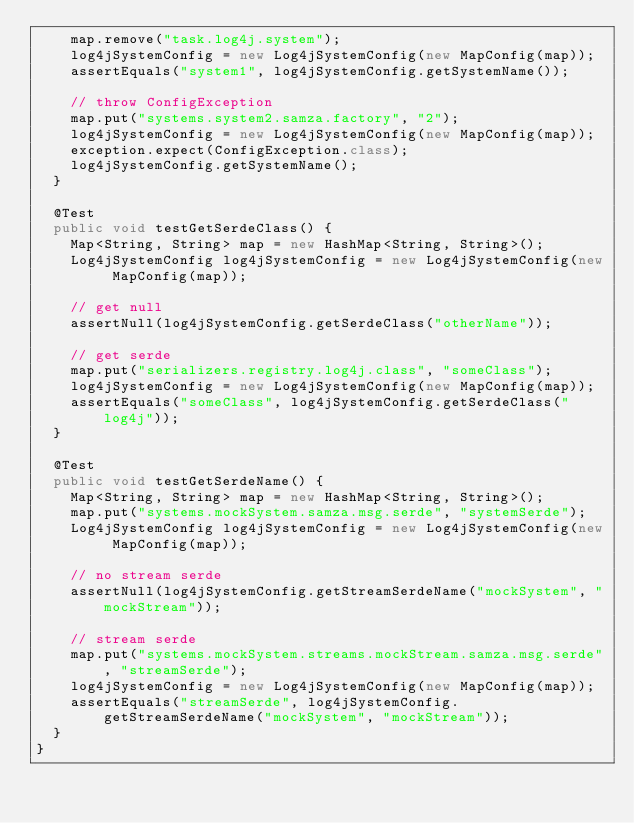<code> <loc_0><loc_0><loc_500><loc_500><_Java_>    map.remove("task.log4j.system");
    log4jSystemConfig = new Log4jSystemConfig(new MapConfig(map));
    assertEquals("system1", log4jSystemConfig.getSystemName());

    // throw ConfigException
    map.put("systems.system2.samza.factory", "2");
    log4jSystemConfig = new Log4jSystemConfig(new MapConfig(map));
    exception.expect(ConfigException.class);
    log4jSystemConfig.getSystemName();
  }

  @Test
  public void testGetSerdeClass() {
    Map<String, String> map = new HashMap<String, String>();
    Log4jSystemConfig log4jSystemConfig = new Log4jSystemConfig(new MapConfig(map));

    // get null
    assertNull(log4jSystemConfig.getSerdeClass("otherName"));

    // get serde
    map.put("serializers.registry.log4j.class", "someClass");
    log4jSystemConfig = new Log4jSystemConfig(new MapConfig(map));
    assertEquals("someClass", log4jSystemConfig.getSerdeClass("log4j"));
  }

  @Test
  public void testGetSerdeName() {
    Map<String, String> map = new HashMap<String, String>();
    map.put("systems.mockSystem.samza.msg.serde", "systemSerde");
    Log4jSystemConfig log4jSystemConfig = new Log4jSystemConfig(new MapConfig(map));

    // no stream serde
    assertNull(log4jSystemConfig.getStreamSerdeName("mockSystem", "mockStream"));

    // stream serde
    map.put("systems.mockSystem.streams.mockStream.samza.msg.serde", "streamSerde");
    log4jSystemConfig = new Log4jSystemConfig(new MapConfig(map));
    assertEquals("streamSerde", log4jSystemConfig.getStreamSerdeName("mockSystem", "mockStream"));
  }
}
</code> 